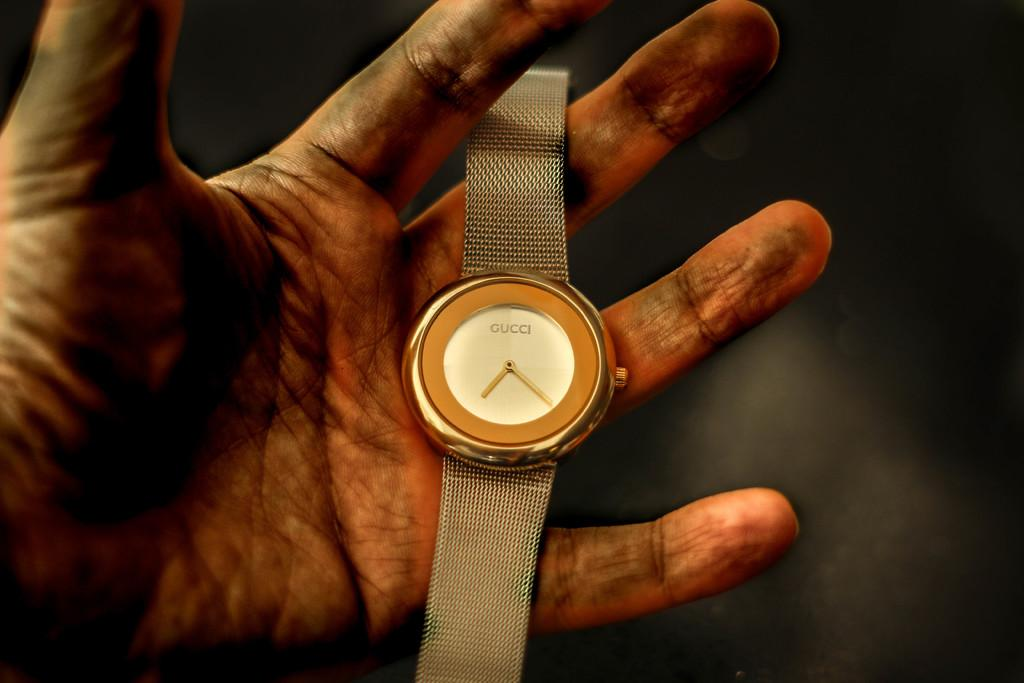<image>
Describe the image concisely. The Gucci watch is setting in a man's dirty hand. 